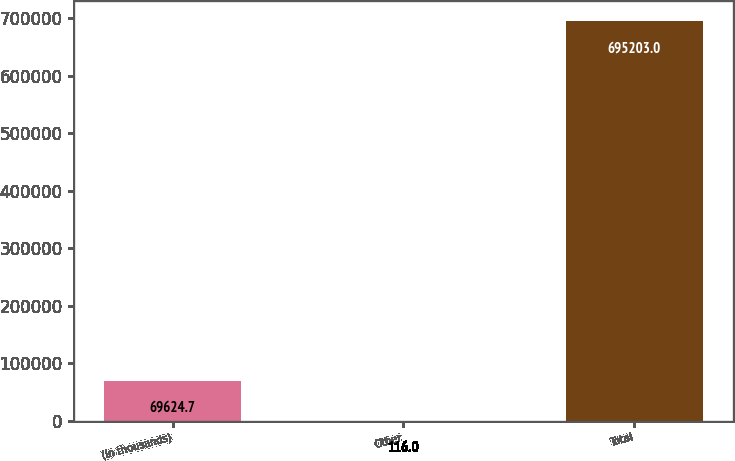Convert chart to OTSL. <chart><loc_0><loc_0><loc_500><loc_500><bar_chart><fcel>(In thousands)<fcel>Other<fcel>Total<nl><fcel>69624.7<fcel>116<fcel>695203<nl></chart> 